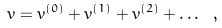<formula> <loc_0><loc_0><loc_500><loc_500>v = v ^ { ( 0 ) } + v ^ { ( 1 ) } + v ^ { ( 2 ) } + \dots \ ,</formula> 